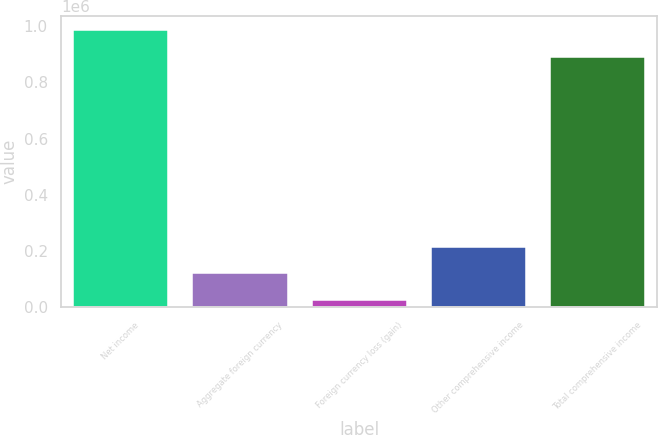Convert chart to OTSL. <chart><loc_0><loc_0><loc_500><loc_500><bar_chart><fcel>Net income<fcel>Aggregate foreign currency<fcel>Foreign currency loss (gain)<fcel>Other comprehensive income<fcel>Total comprehensive income<nl><fcel>986727<fcel>120213<fcel>25362<fcel>215064<fcel>891876<nl></chart> 